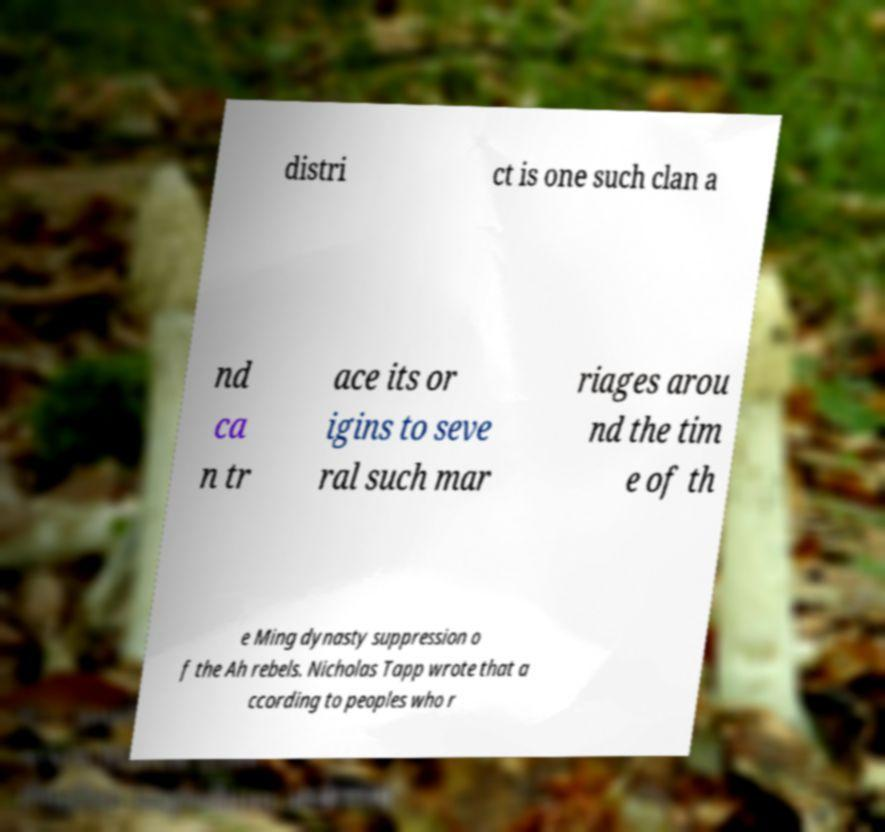Can you read and provide the text displayed in the image?This photo seems to have some interesting text. Can you extract and type it out for me? distri ct is one such clan a nd ca n tr ace its or igins to seve ral such mar riages arou nd the tim e of th e Ming dynasty suppression o f the Ah rebels. Nicholas Tapp wrote that a ccording to peoples who r 